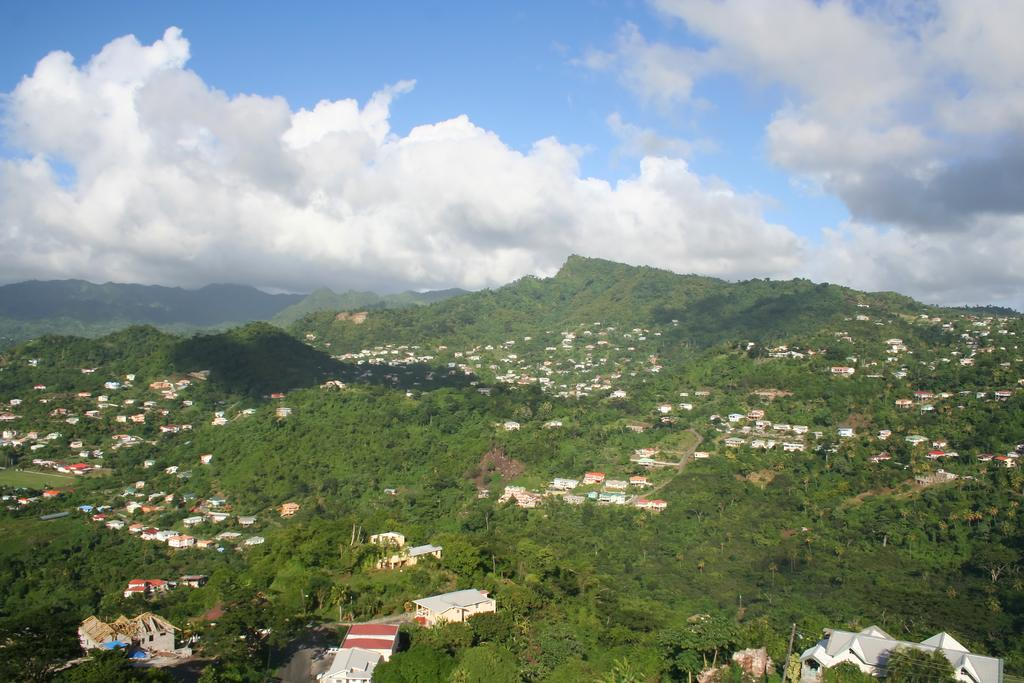What type of vegetation is present at the bottom of the image? There are trees and grass at the bottom of the image. What type of landscape feature is present at the bottom of the image? There are hills at the bottom of the image. What type of structures are present at the bottom of the image? There are houses at the bottom of the image. What is visible at the top of the image? The sky is visible at the top of the image. What is the condition of the sky in the image? The sky is cloudy in the image. Can you tell me how many birds are carrying a yoke in the image? There are no birds or yokes present in the image. What type of bread is visible in the image? There is no bread, specifically a loaf, present in the image. 